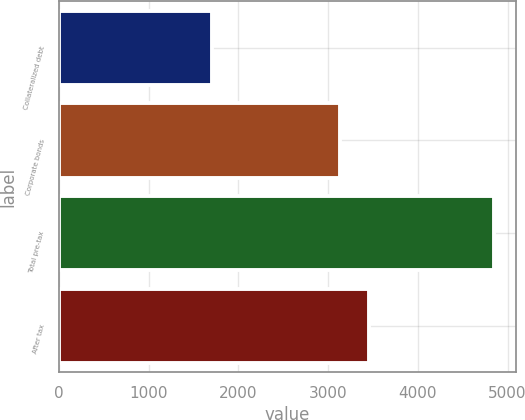<chart> <loc_0><loc_0><loc_500><loc_500><bar_chart><fcel>Collateralized debt<fcel>Corporate bonds<fcel>Total pre-tax<fcel>After tax<nl><fcel>1712<fcel>3138<fcel>4850<fcel>3451.8<nl></chart> 